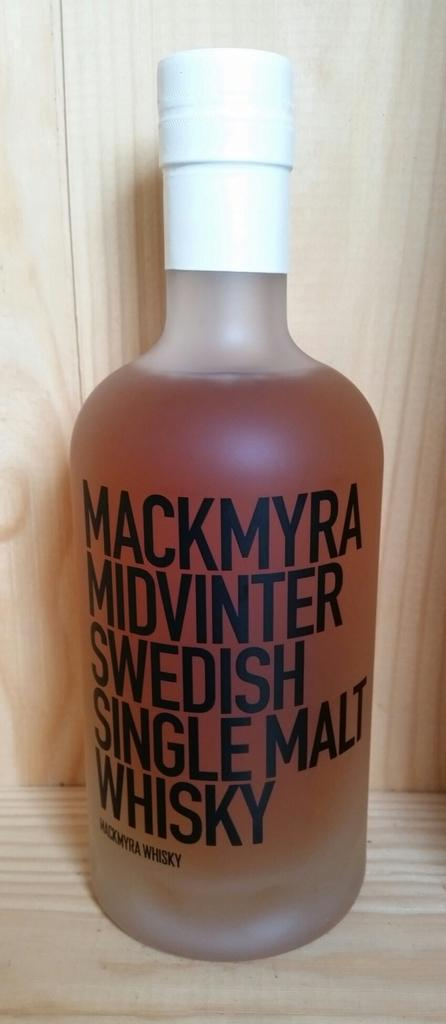<image>
Share a concise interpretation of the image provided. An open bottled of Mackmyra Midvinter Swedish Single Malt Whisky. 